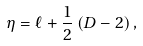<formula> <loc_0><loc_0><loc_500><loc_500>\eta = \ell + \frac { 1 } { 2 } \left ( D - 2 \right ) ,</formula> 